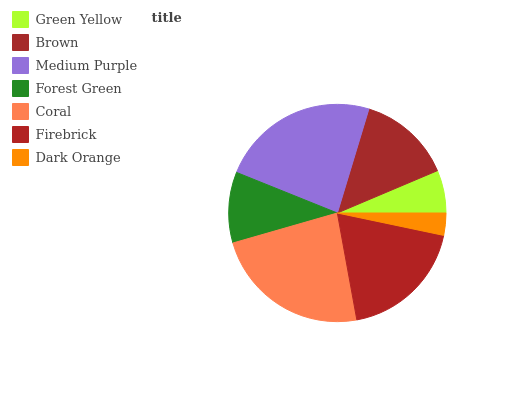Is Dark Orange the minimum?
Answer yes or no. Yes. Is Medium Purple the maximum?
Answer yes or no. Yes. Is Brown the minimum?
Answer yes or no. No. Is Brown the maximum?
Answer yes or no. No. Is Brown greater than Green Yellow?
Answer yes or no. Yes. Is Green Yellow less than Brown?
Answer yes or no. Yes. Is Green Yellow greater than Brown?
Answer yes or no. No. Is Brown less than Green Yellow?
Answer yes or no. No. Is Brown the high median?
Answer yes or no. Yes. Is Brown the low median?
Answer yes or no. Yes. Is Dark Orange the high median?
Answer yes or no. No. Is Firebrick the low median?
Answer yes or no. No. 